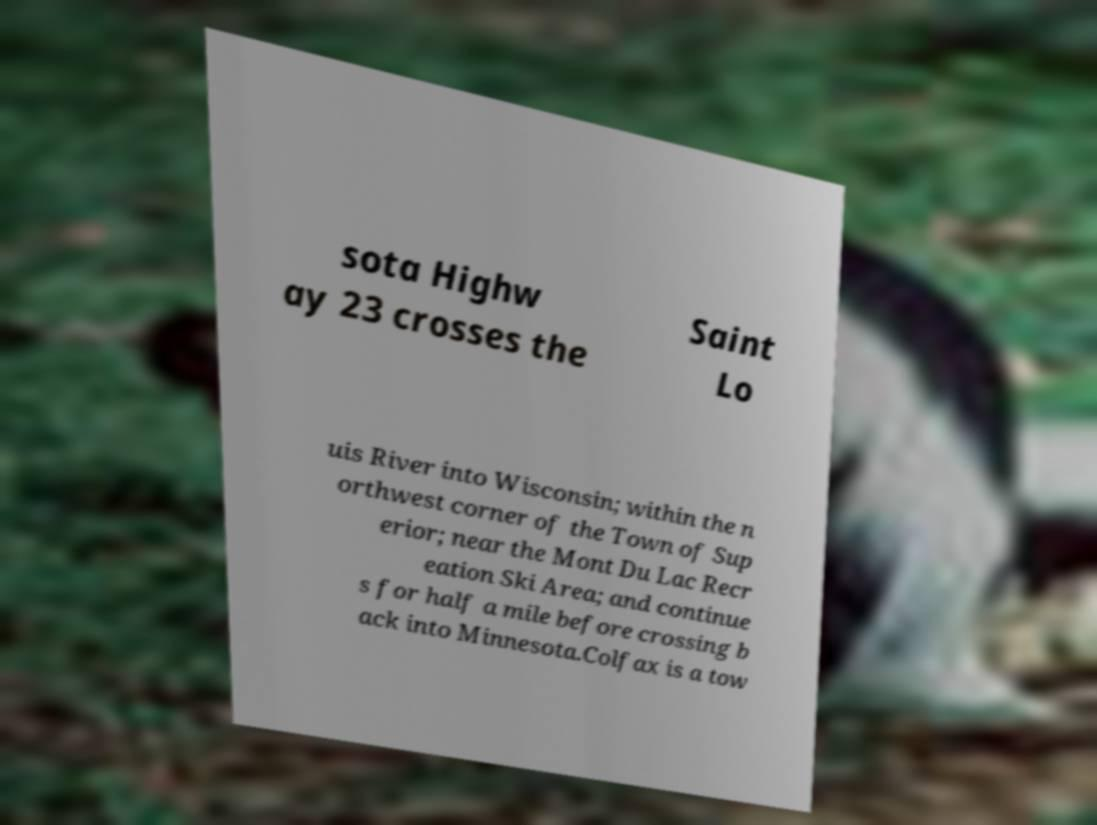What messages or text are displayed in this image? I need them in a readable, typed format. sota Highw ay 23 crosses the Saint Lo uis River into Wisconsin; within the n orthwest corner of the Town of Sup erior; near the Mont Du Lac Recr eation Ski Area; and continue s for half a mile before crossing b ack into Minnesota.Colfax is a tow 